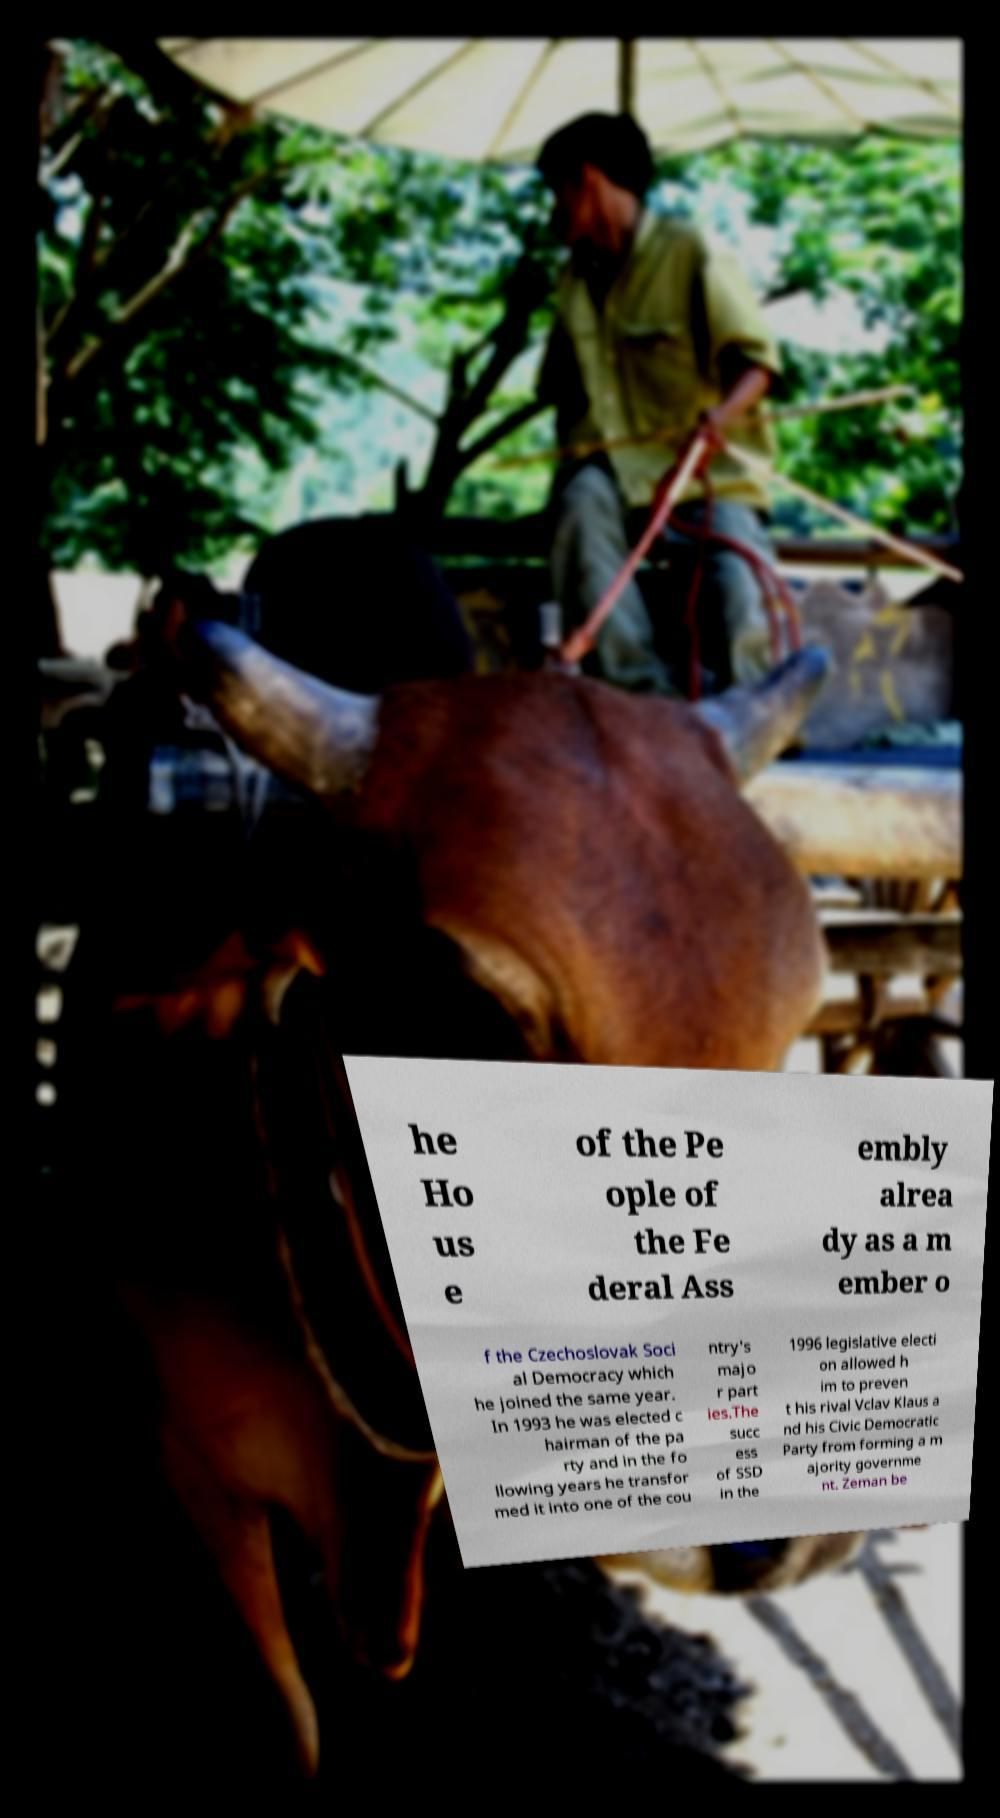There's text embedded in this image that I need extracted. Can you transcribe it verbatim? he Ho us e of the Pe ople of the Fe deral Ass embly alrea dy as a m ember o f the Czechoslovak Soci al Democracy which he joined the same year. In 1993 he was elected c hairman of the pa rty and in the fo llowing years he transfor med it into one of the cou ntry's majo r part ies.The succ ess of SSD in the 1996 legislative electi on allowed h im to preven t his rival Vclav Klaus a nd his Civic Democratic Party from forming a m ajority governme nt. Zeman be 